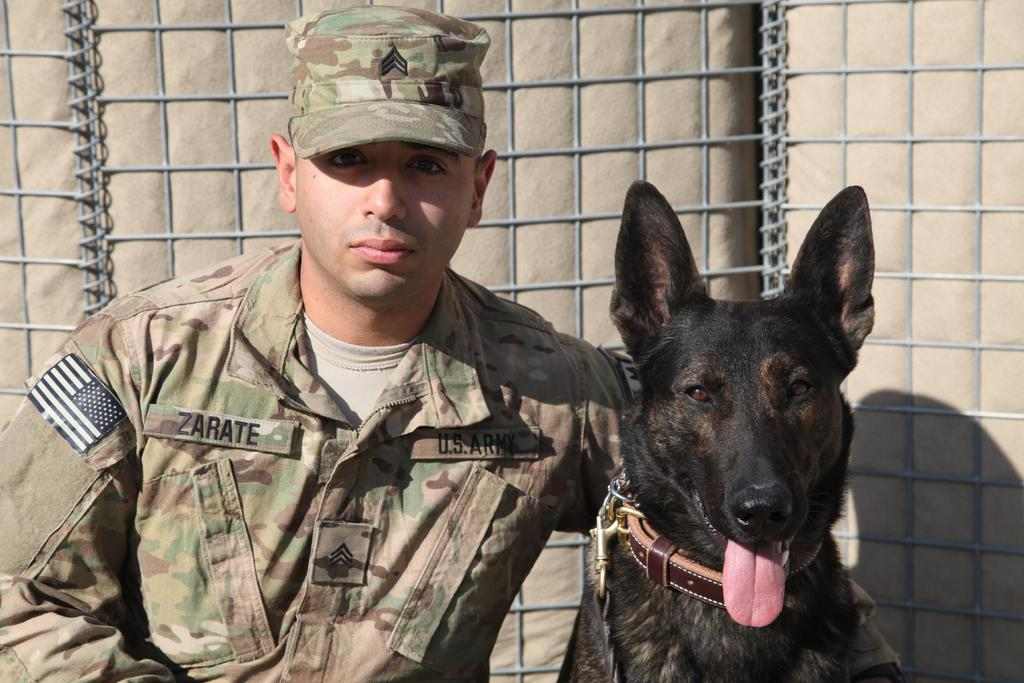Who or what is present in the image with the person? There is a dog in the image with the person. What is the person wearing in the image? The person is wearing clothes and a cap. What can be seen in the background of the image? There are grills in the background of the image. Can you tell me how many dinosaurs are walking in the image? There are no dinosaurs present in the image, and therefore no such activity can be observed. 